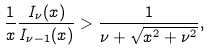<formula> <loc_0><loc_0><loc_500><loc_500>\frac { 1 } { x } \frac { I _ { \nu } ( x ) } { I _ { \nu - 1 } ( x ) } > \frac { 1 } { \nu + \sqrt { x ^ { 2 } + \nu ^ { 2 } } } ,</formula> 